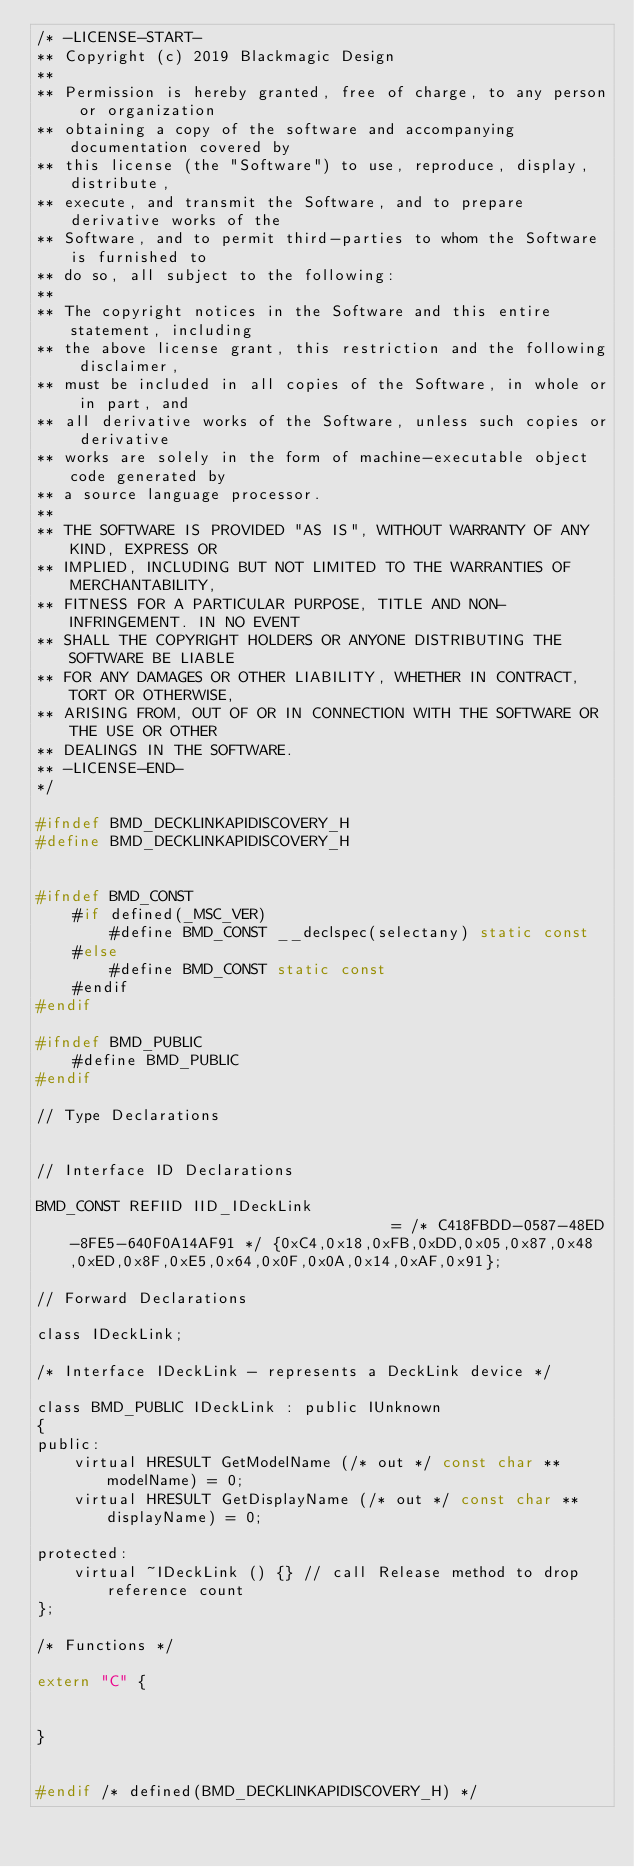<code> <loc_0><loc_0><loc_500><loc_500><_C_>/* -LICENSE-START-
** Copyright (c) 2019 Blackmagic Design
**
** Permission is hereby granted, free of charge, to any person or organization
** obtaining a copy of the software and accompanying documentation covered by
** this license (the "Software") to use, reproduce, display, distribute,
** execute, and transmit the Software, and to prepare derivative works of the
** Software, and to permit third-parties to whom the Software is furnished to
** do so, all subject to the following:
** 
** The copyright notices in the Software and this entire statement, including
** the above license grant, this restriction and the following disclaimer,
** must be included in all copies of the Software, in whole or in part, and
** all derivative works of the Software, unless such copies or derivative
** works are solely in the form of machine-executable object code generated by
** a source language processor.
** 
** THE SOFTWARE IS PROVIDED "AS IS", WITHOUT WARRANTY OF ANY KIND, EXPRESS OR
** IMPLIED, INCLUDING BUT NOT LIMITED TO THE WARRANTIES OF MERCHANTABILITY,
** FITNESS FOR A PARTICULAR PURPOSE, TITLE AND NON-INFRINGEMENT. IN NO EVENT
** SHALL THE COPYRIGHT HOLDERS OR ANYONE DISTRIBUTING THE SOFTWARE BE LIABLE
** FOR ANY DAMAGES OR OTHER LIABILITY, WHETHER IN CONTRACT, TORT OR OTHERWISE,
** ARISING FROM, OUT OF OR IN CONNECTION WITH THE SOFTWARE OR THE USE OR OTHER
** DEALINGS IN THE SOFTWARE.
** -LICENSE-END-
*/

#ifndef BMD_DECKLINKAPIDISCOVERY_H
#define BMD_DECKLINKAPIDISCOVERY_H


#ifndef BMD_CONST
    #if defined(_MSC_VER)
        #define BMD_CONST __declspec(selectany) static const
    #else
        #define BMD_CONST static const
    #endif
#endif

#ifndef BMD_PUBLIC
	#define BMD_PUBLIC
#endif

// Type Declarations


// Interface ID Declarations

BMD_CONST REFIID IID_IDeckLink                                    = /* C418FBDD-0587-48ED-8FE5-640F0A14AF91 */ {0xC4,0x18,0xFB,0xDD,0x05,0x87,0x48,0xED,0x8F,0xE5,0x64,0x0F,0x0A,0x14,0xAF,0x91};

// Forward Declarations

class IDeckLink;

/* Interface IDeckLink - represents a DeckLink device */

class BMD_PUBLIC IDeckLink : public IUnknown
{
public:
    virtual HRESULT GetModelName (/* out */ const char **modelName) = 0;
    virtual HRESULT GetDisplayName (/* out */ const char **displayName) = 0;

protected:
    virtual ~IDeckLink () {} // call Release method to drop reference count
};

/* Functions */

extern "C" {


}


#endif /* defined(BMD_DECKLINKAPIDISCOVERY_H) */
</code> 